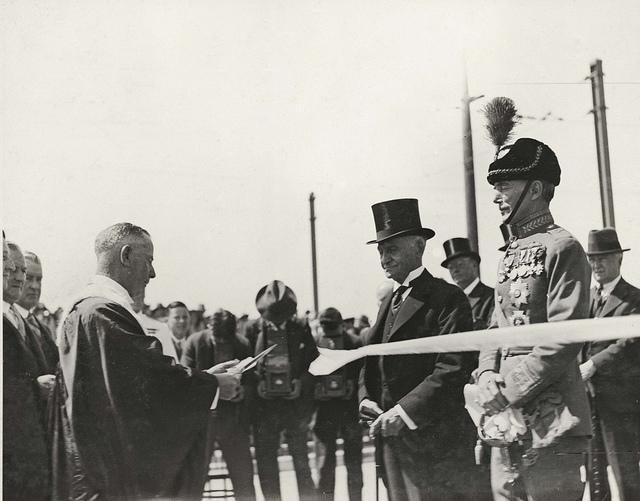Is this pic black and white?
Quick response, please. Yes. Is this priest blessing an opening ceremony?
Be succinct. Yes. What country are these people from?
Be succinct. England. 